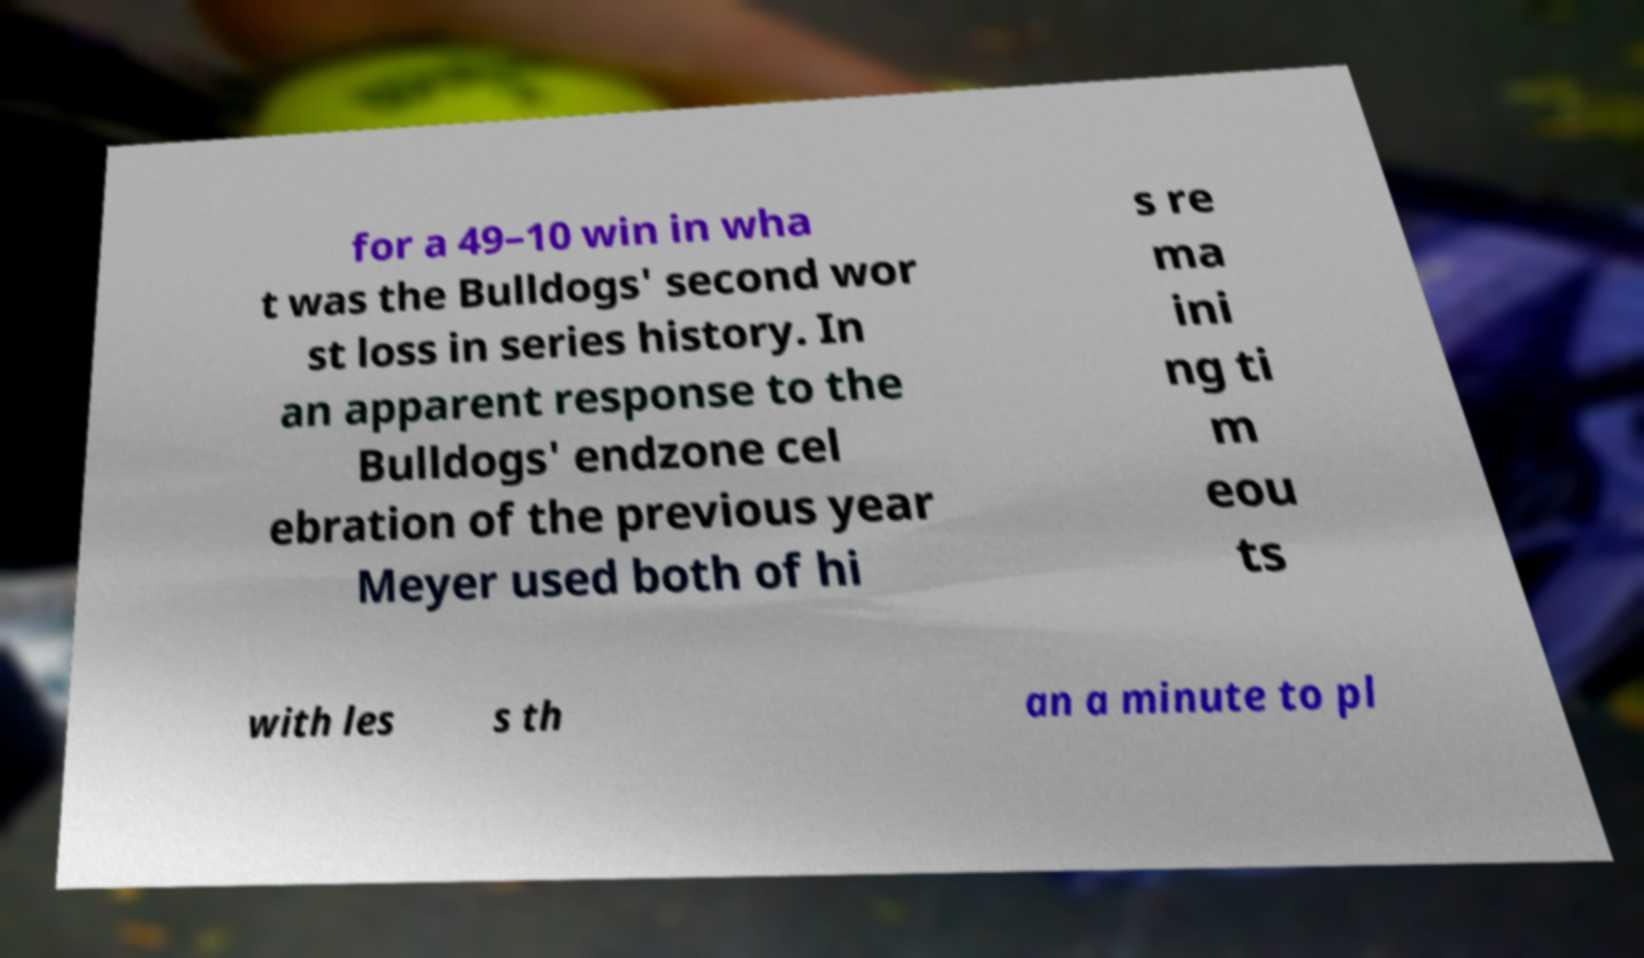Can you read and provide the text displayed in the image?This photo seems to have some interesting text. Can you extract and type it out for me? for a 49–10 win in wha t was the Bulldogs' second wor st loss in series history. In an apparent response to the Bulldogs' endzone cel ebration of the previous year Meyer used both of hi s re ma ini ng ti m eou ts with les s th an a minute to pl 